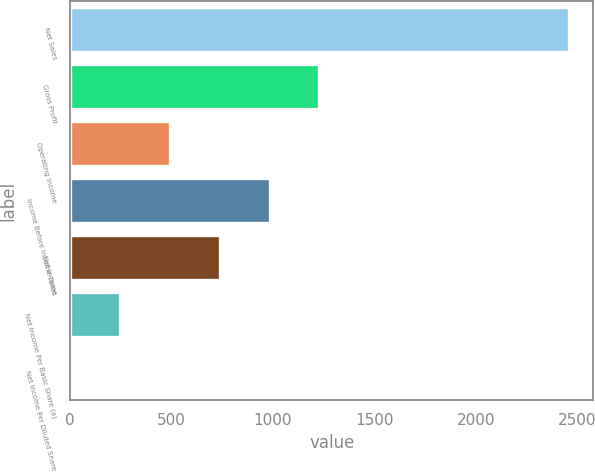<chart> <loc_0><loc_0><loc_500><loc_500><bar_chart><fcel>Net Sales<fcel>Gross Profit<fcel>Operating Income<fcel>Income Before Income Taxes<fcel>Net Income<fcel>Net Income Per Basic Share (a)<fcel>Net Income Per Diluted Share<nl><fcel>2458<fcel>1229.38<fcel>492.19<fcel>983.65<fcel>737.92<fcel>246.46<fcel>0.73<nl></chart> 